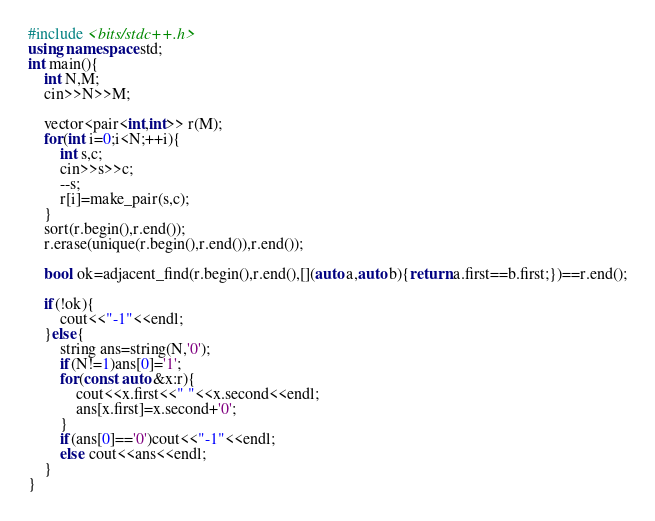Convert code to text. <code><loc_0><loc_0><loc_500><loc_500><_C++_>#include <bits/stdc++.h>
using namespace std;
int main(){
    int N,M;
    cin>>N>>M;
    
    vector<pair<int,int>> r(M);
    for(int i=0;i<N;++i){
        int s,c;
        cin>>s>>c;
        --s;
        r[i]=make_pair(s,c);
    }
    sort(r.begin(),r.end());
    r.erase(unique(r.begin(),r.end()),r.end());
    
    bool ok=adjacent_find(r.begin(),r.end(),[](auto a,auto b){return a.first==b.first;})==r.end();

    if(!ok){
        cout<<"-1"<<endl;
    }else{
        string ans=string(N,'0');
        if(N!=1)ans[0]='1';
        for(const auto &x:r){
            cout<<x.first<<" "<<x.second<<endl;
            ans[x.first]=x.second+'0';
        }
        if(ans[0]=='0')cout<<"-1"<<endl;
        else cout<<ans<<endl;
    }
}
</code> 